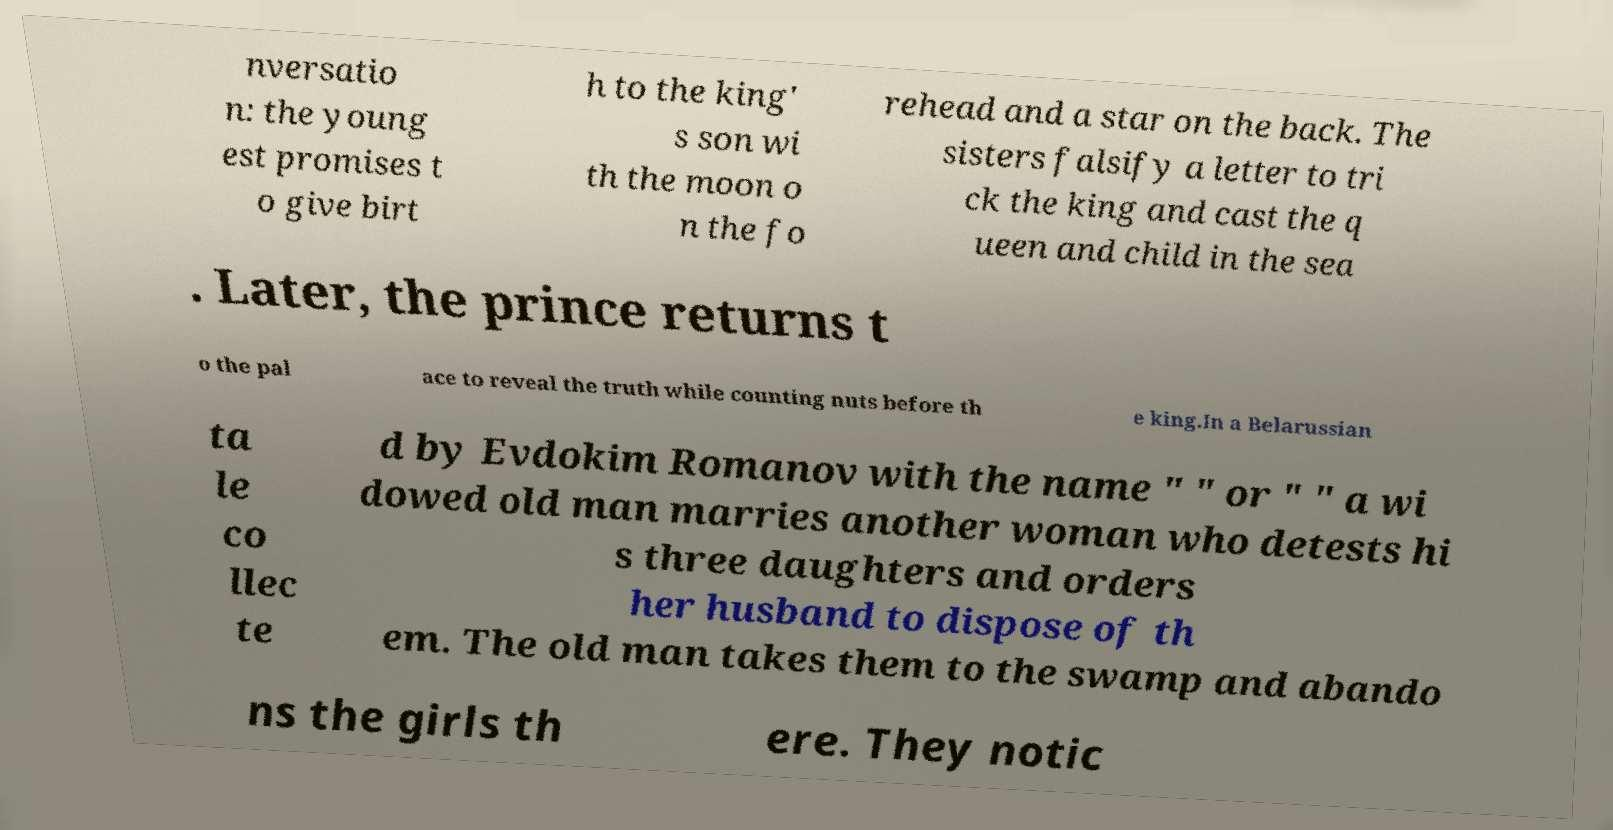Can you read and provide the text displayed in the image?This photo seems to have some interesting text. Can you extract and type it out for me? nversatio n: the young est promises t o give birt h to the king' s son wi th the moon o n the fo rehead and a star on the back. The sisters falsify a letter to tri ck the king and cast the q ueen and child in the sea . Later, the prince returns t o the pal ace to reveal the truth while counting nuts before th e king.In a Belarussian ta le co llec te d by Evdokim Romanov with the name " " or " " a wi dowed old man marries another woman who detests hi s three daughters and orders her husband to dispose of th em. The old man takes them to the swamp and abando ns the girls th ere. They notic 